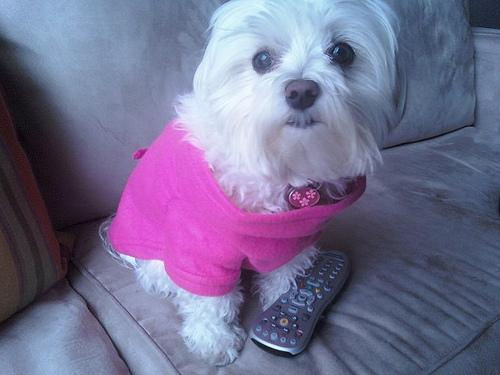What object is the item under the dog linked to? television 